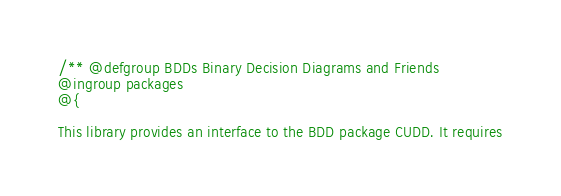<code> <loc_0><loc_0><loc_500><loc_500><_Prolog_>/** @defgroup BDDs Binary Decision Diagrams and Friends
@ingroup packages
@{

This library provides an interface to the BDD package CUDD. It requires</code> 